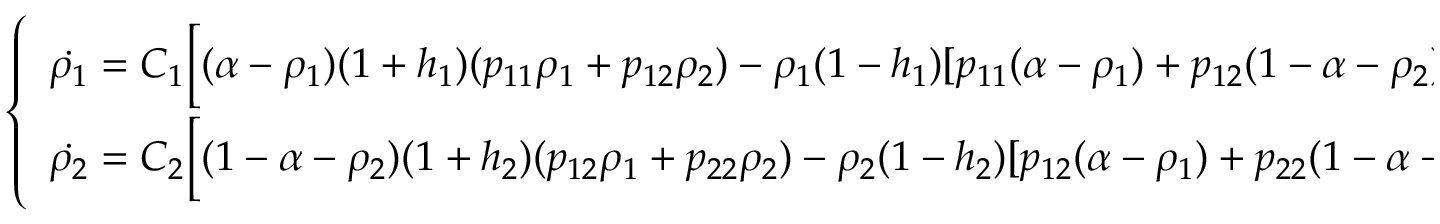<formula> <loc_0><loc_0><loc_500><loc_500>\left \{ \begin{array} { l l } { \dot { \rho _ { 1 } } = C _ { 1 } \left [ ( \alpha - \rho _ { 1 } ) ( 1 + h _ { 1 } ) ( p _ { 1 1 } \rho _ { 1 } + p _ { 1 2 } \rho _ { 2 } ) - \rho _ { 1 } ( 1 - h _ { 1 } ) [ p _ { 1 1 } ( \alpha - \rho _ { 1 } ) + p _ { 1 2 } ( 1 - \alpha - \rho _ { 2 } ) ] \right ] } \\ { \dot { \rho _ { 2 } } = C _ { 2 } \left [ ( 1 - \alpha - \rho _ { 2 } ) ( 1 + h _ { 2 } ) ( p _ { 1 2 } \rho _ { 1 } + p _ { 2 2 } \rho _ { 2 } ) - \rho _ { 2 } ( 1 - h _ { 2 } ) [ p _ { 1 2 } ( \alpha - \rho _ { 1 } ) + p _ { 2 2 } ( 1 - \alpha - \rho _ { 2 } ) ] \right ] } \end{array}</formula> 